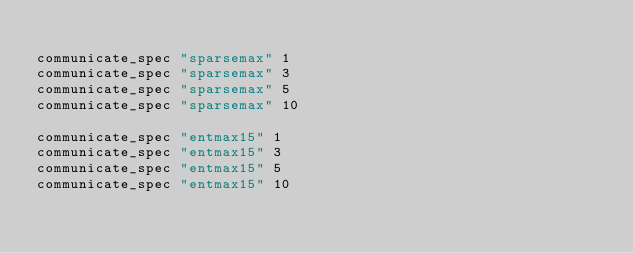Convert code to text. <code><loc_0><loc_0><loc_500><loc_500><_Bash_>
communicate_spec "sparsemax" 1
communicate_spec "sparsemax" 3
communicate_spec "sparsemax" 5
communicate_spec "sparsemax" 10

communicate_spec "entmax15" 1
communicate_spec "entmax15" 3
communicate_spec "entmax15" 5
communicate_spec "entmax15" 10
</code> 